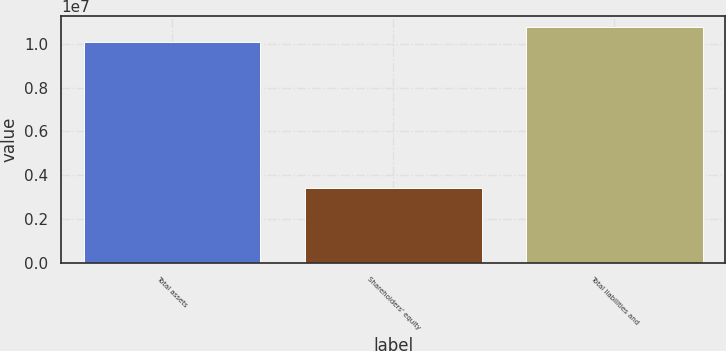Convert chart to OTSL. <chart><loc_0><loc_0><loc_500><loc_500><bar_chart><fcel>Total assets<fcel>Shareholders' equity<fcel>Total liabilities and<nl><fcel>1.00823e+07<fcel>3.40899e+06<fcel>1.07496e+07<nl></chart> 